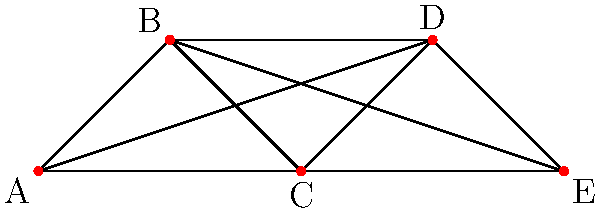In designing a new dark matter detector, you need to optimize the layout of sensors to minimize interference. The graph represents potential sensor positions, where each vertex is a sensor and edges indicate potential interference between sensors. What is the minimum number of colors needed to color the graph such that no two adjacent vertices have the same color, and what does this represent in terms of sensor groups? To solve this problem, we'll use the concept of graph coloring:

1. First, we need to understand what the graph coloring represents in this context:
   - Each color represents a group of sensors that can operate simultaneously without interference.
   - Adjacent vertices (connected by an edge) cannot have the same color, as this would represent interfering sensors.

2. Now, let's color the graph step by step:
   - Start with vertex A: Assign it color 1.
   - Vertex B is connected to A, so it needs a different color: Assign it color 2.
   - Vertex C is connected to both A and B, so it needs a new color: Assign it color 3.
   - Vertex D is connected to A, B, and C, so it needs a new color: Assign it color 4.
   - Vertex E is connected to all other vertices, so it needs a new color: Assign it color 5.

3. We've used 5 colors in total, and this is the minimum number possible for this graph.

4. In terms of sensor groups, this means:
   - We need at least 5 different time slots or frequencies for the sensors to operate without interference.
   - Each color represents a group of sensors that can be active simultaneously.

5. This coloring is also known as the chromatic number of the graph, which in this case is 5.

The significance for the dark matter detector is that we need to divide the sensors into at least 5 groups to avoid interference, which could be achieved by either:
a) Operating each group at different times in a cycle.
b) Using 5 different frequencies for the sensor groups.

This optimization ensures maximum sensitivity of the detector by minimizing interference between sensors.
Answer: 5 colors; 5 non-interfering sensor groups 